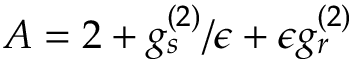Convert formula to latex. <formula><loc_0><loc_0><loc_500><loc_500>A = 2 + g _ { s } ^ { ( 2 ) } / \epsilon + \epsilon g _ { r } ^ { ( 2 ) }</formula> 